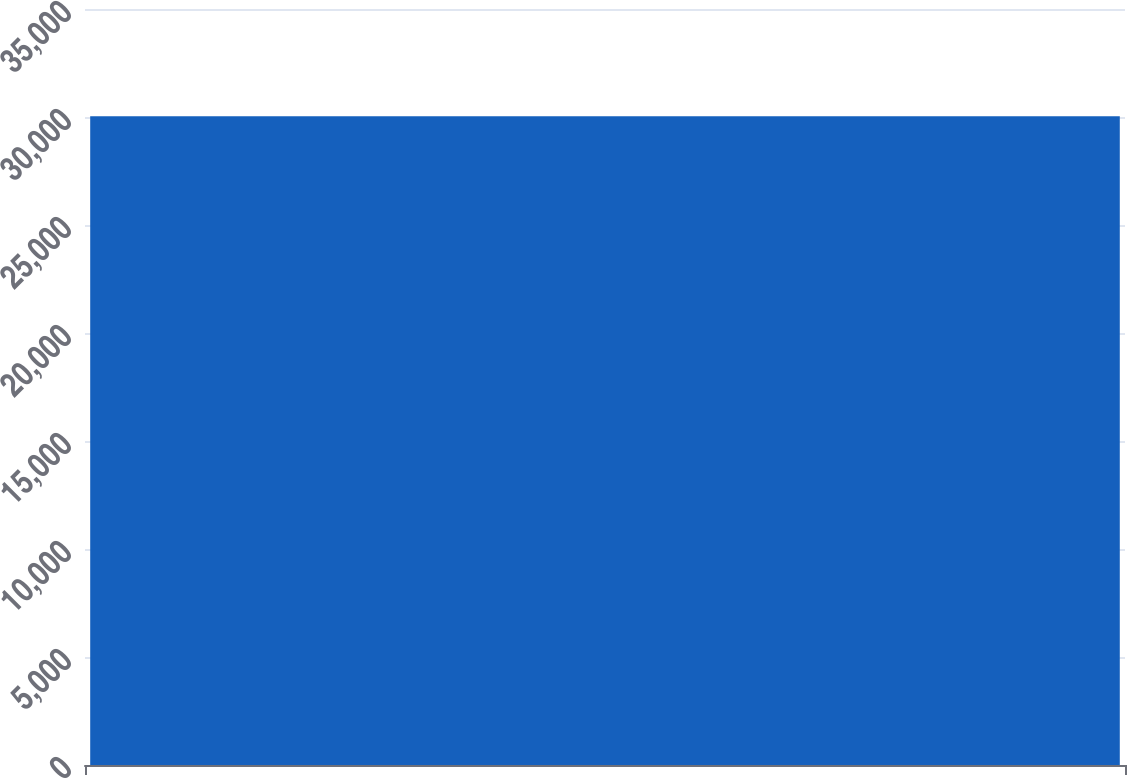<chart> <loc_0><loc_0><loc_500><loc_500><bar_chart><ecel><nl><fcel>30033.7<nl></chart> 